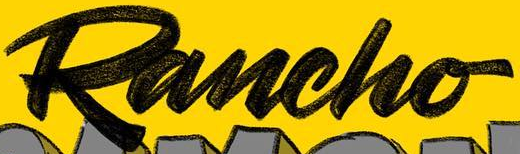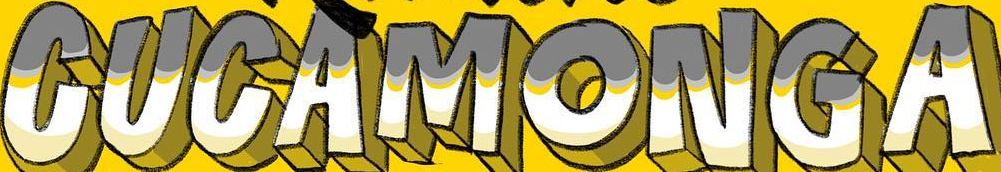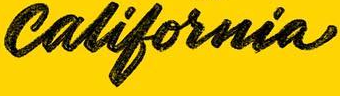Identify the words shown in these images in order, separated by a semicolon. Rancho; CUCAMONGA; california 